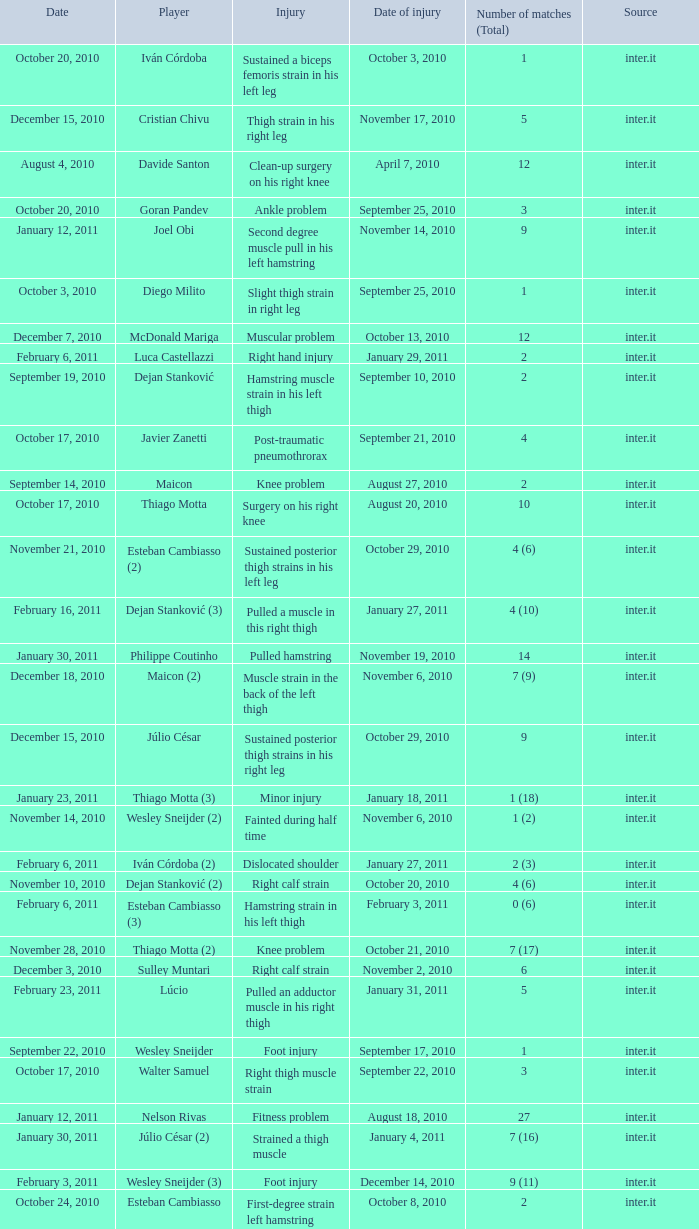Can you parse all the data within this table? {'header': ['Date', 'Player', 'Injury', 'Date of injury', 'Number of matches (Total)', 'Source'], 'rows': [['October 20, 2010', 'Iván Córdoba', 'Sustained a biceps femoris strain in his left leg', 'October 3, 2010', '1', 'inter.it'], ['December 15, 2010', 'Cristian Chivu', 'Thigh strain in his right leg', 'November 17, 2010', '5', 'inter.it'], ['August 4, 2010', 'Davide Santon', 'Clean-up surgery on his right knee', 'April 7, 2010', '12', 'inter.it'], ['October 20, 2010', 'Goran Pandev', 'Ankle problem', 'September 25, 2010', '3', 'inter.it'], ['January 12, 2011', 'Joel Obi', 'Second degree muscle pull in his left hamstring', 'November 14, 2010', '9', 'inter.it'], ['October 3, 2010', 'Diego Milito', 'Slight thigh strain in right leg', 'September 25, 2010', '1', 'inter.it'], ['December 7, 2010', 'McDonald Mariga', 'Muscular problem', 'October 13, 2010', '12', 'inter.it'], ['February 6, 2011', 'Luca Castellazzi', 'Right hand injury', 'January 29, 2011', '2', 'inter.it'], ['September 19, 2010', 'Dejan Stanković', 'Hamstring muscle strain in his left thigh', 'September 10, 2010', '2', 'inter.it'], ['October 17, 2010', 'Javier Zanetti', 'Post-traumatic pneumothrorax', 'September 21, 2010', '4', 'inter.it'], ['September 14, 2010', 'Maicon', 'Knee problem', 'August 27, 2010', '2', 'inter.it'], ['October 17, 2010', 'Thiago Motta', 'Surgery on his right knee', 'August 20, 2010', '10', 'inter.it'], ['November 21, 2010', 'Esteban Cambiasso (2)', 'Sustained posterior thigh strains in his left leg', 'October 29, 2010', '4 (6)', 'inter.it'], ['February 16, 2011', 'Dejan Stanković (3)', 'Pulled a muscle in this right thigh', 'January 27, 2011', '4 (10)', 'inter.it'], ['January 30, 2011', 'Philippe Coutinho', 'Pulled hamstring', 'November 19, 2010', '14', 'inter.it'], ['December 18, 2010', 'Maicon (2)', 'Muscle strain in the back of the left thigh', 'November 6, 2010', '7 (9)', 'inter.it'], ['December 15, 2010', 'Júlio César', 'Sustained posterior thigh strains in his right leg', 'October 29, 2010', '9', 'inter.it'], ['January 23, 2011', 'Thiago Motta (3)', 'Minor injury', 'January 18, 2011', '1 (18)', 'inter.it'], ['November 14, 2010', 'Wesley Sneijder (2)', 'Fainted during half time', 'November 6, 2010', '1 (2)', 'inter.it'], ['February 6, 2011', 'Iván Córdoba (2)', 'Dislocated shoulder', 'January 27, 2011', '2 (3)', 'inter.it'], ['November 10, 2010', 'Dejan Stanković (2)', 'Right calf strain', 'October 20, 2010', '4 (6)', 'inter.it'], ['February 6, 2011', 'Esteban Cambiasso (3)', 'Hamstring strain in his left thigh', 'February 3, 2011', '0 (6)', 'inter.it'], ['November 28, 2010', 'Thiago Motta (2)', 'Knee problem', 'October 21, 2010', '7 (17)', 'inter.it'], ['December 3, 2010', 'Sulley Muntari', 'Right calf strain', 'November 2, 2010', '6', 'inter.it'], ['February 23, 2011', 'Lúcio', 'Pulled an adductor muscle in his right thigh', 'January 31, 2011', '5', 'inter.it'], ['September 22, 2010', 'Wesley Sneijder', 'Foot injury', 'September 17, 2010', '1', 'inter.it'], ['October 17, 2010', 'Walter Samuel', 'Right thigh muscle strain', 'September 22, 2010', '3', 'inter.it'], ['January 12, 2011', 'Nelson Rivas', 'Fitness problem', 'August 18, 2010', '27', 'inter.it'], ['January 30, 2011', 'Júlio César (2)', 'Strained a thigh muscle', 'January 4, 2011', '7 (16)', 'inter.it'], ['February 3, 2011', 'Wesley Sneijder (3)', 'Foot injury', 'December 14, 2010', '9 (11)', 'inter.it'], ['October 24, 2010', 'Esteban Cambiasso', 'First-degree strain left hamstring muscles', 'October 8, 2010', '2', 'inter.it']]} What is the date of injury when the injury is foot injury and the number of matches (total) is 1? September 17, 2010. 